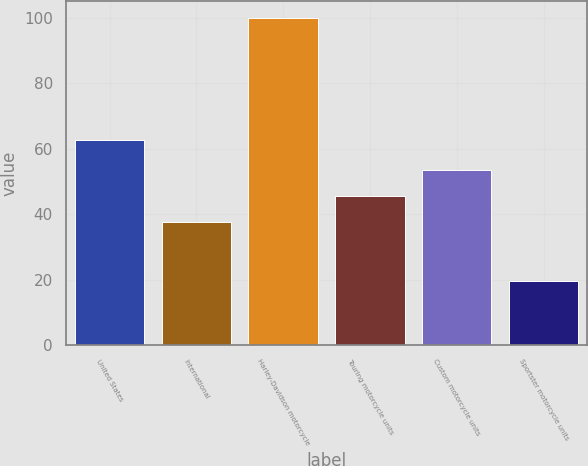Convert chart to OTSL. <chart><loc_0><loc_0><loc_500><loc_500><bar_chart><fcel>United States<fcel>International<fcel>Harley-Davidson motorcycle<fcel>Touring motorcycle units<fcel>Custom motorcycle units<fcel>Sportster motorcycle units<nl><fcel>62.5<fcel>37.5<fcel>100<fcel>45.53<fcel>53.56<fcel>19.7<nl></chart> 